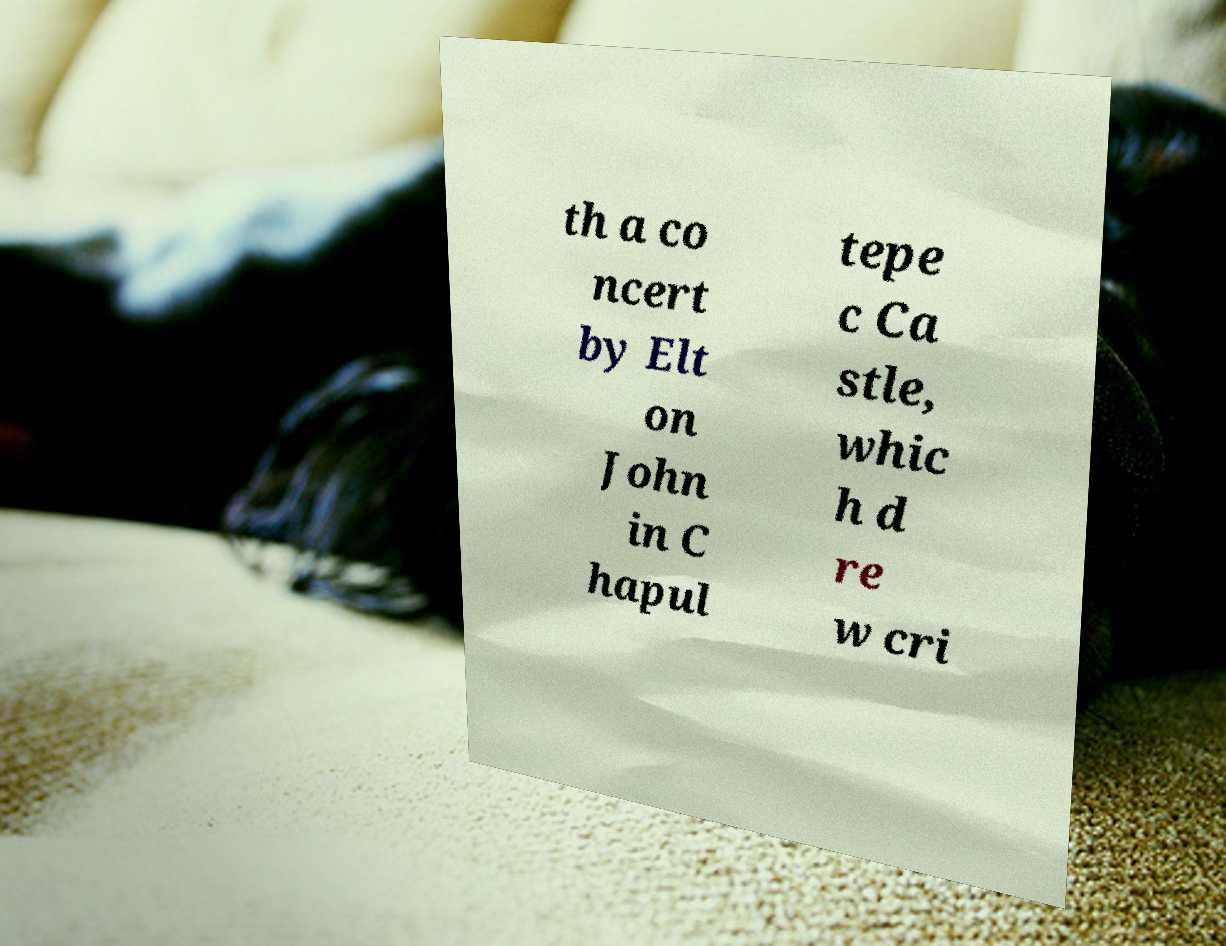Could you extract and type out the text from this image? th a co ncert by Elt on John in C hapul tepe c Ca stle, whic h d re w cri 